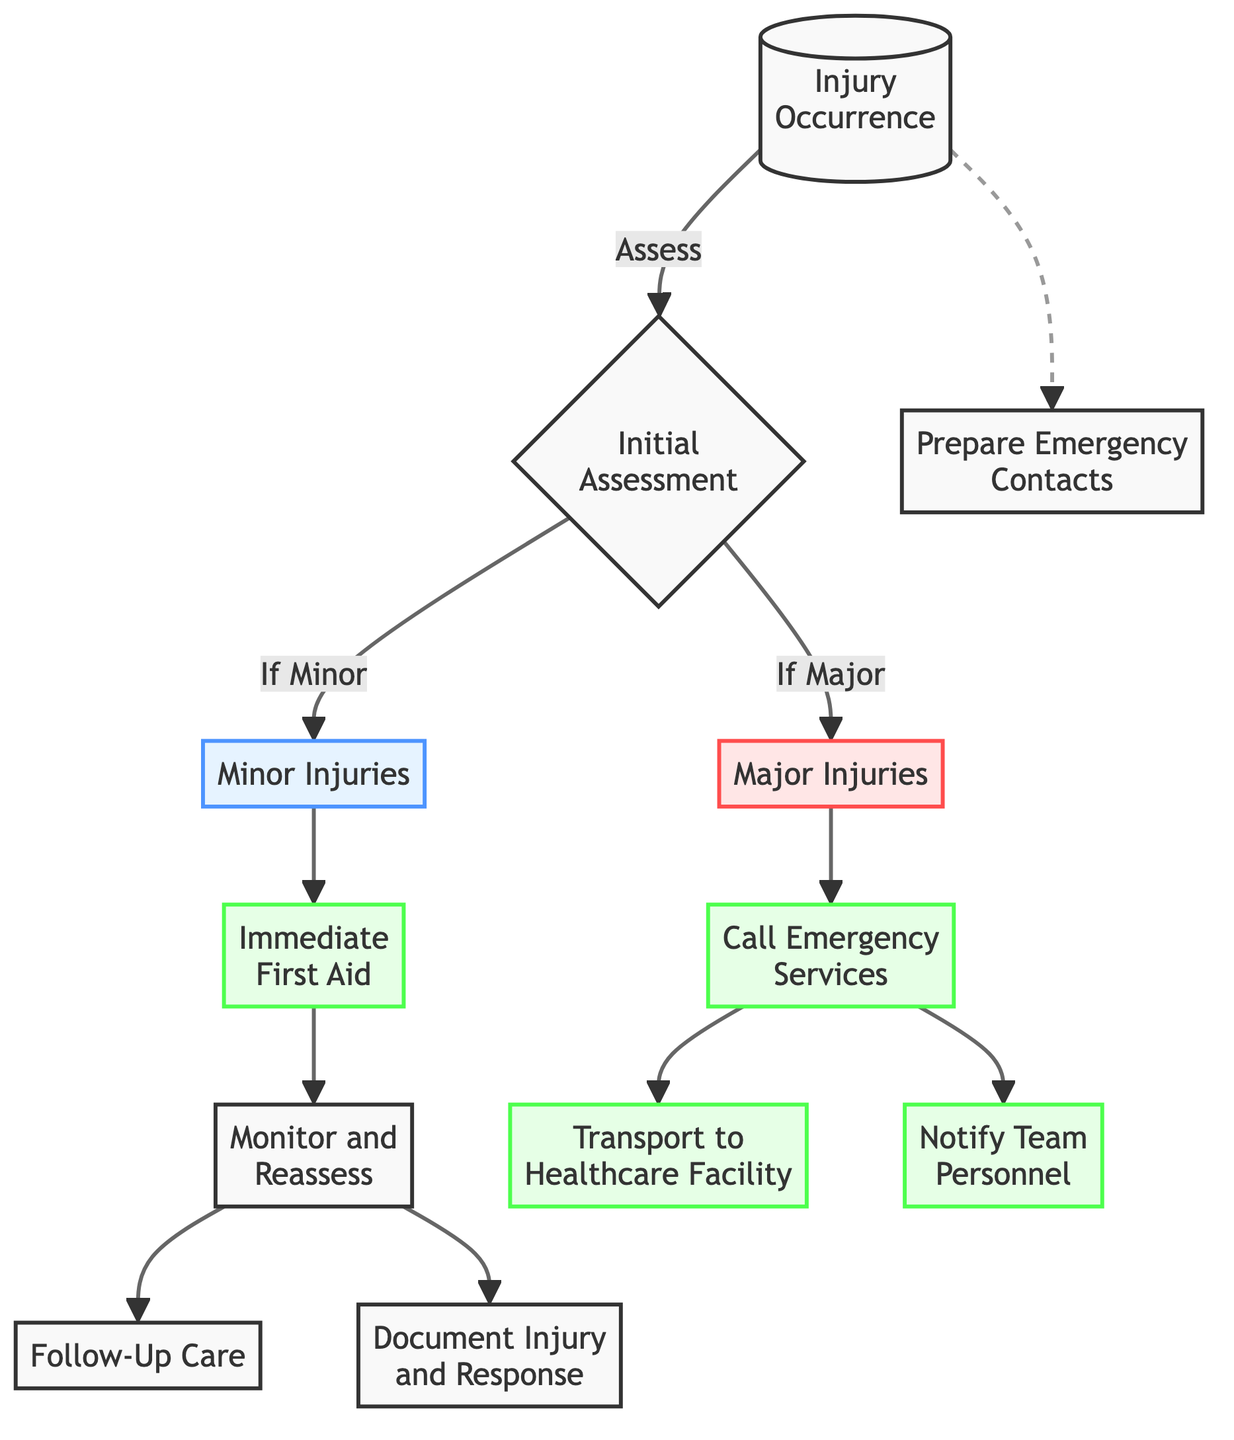What is the first step after an injury occurs? The first step after an injury occurs is to perform an "Initial Assessment," which is represented directly by the node following "Injury Occurrence."
Answer: Initial Assessment How many types of injuries are identified in the diagram? The diagram identifies two types of injuries: "Minor Injuries" and "Major Injuries." These are represented as two separate nodes stemming from the "Initial Assessment" node.
Answer: Two What action should be taken for a minor injury? For a minor injury, the action that should be taken is "Immediate First Aid," as indicated directly following the "Minor Injuries" node.
Answer: Immediate First Aid What happens after notifying team personnel? After notifying team personnel, the next action is "Transport to Healthcare Facility" when dealing with major injuries, as indicated in the diagram flow.
Answer: Transport to Healthcare Facility If an assessment indicates a major injury, what is the first action? If an assessment indicates a major injury, the first action is to "Call Emergency Services," directly following the "Major Injuries" node in the flow.
Answer: Call Emergency Services How many follow-up actions are prompted after monitoring and reassessing? After monitoring and reassessing the situation, there are two follow-up actions prompted: "Document Injury and Response" and "Follow-Up Care." Therefore, the answer is two actions.
Answer: Two actions Which type of injury is associated with the color code "majorStyle"? The "Major Injuries" node is associated with the color code "majorStyle," which is represented in the diagram as a red style.
Answer: Major Injuries What is the relationship between "Initial Assessment" and "Monitor and Reassess"? The relationship is sequential; after the "Initial Assessment" is completed, the flow leads to monitoring and reassessing the injury condition, indicating a stepwise approach to handling injuries.
Answer: Sequential What node does "Prepare Emergency Contacts" connect to, and what type of relationship is depicted? The "Prepare Emergency Contacts" node has a dashed line connecting to the "Injury Occurrence," indicating a non-sequential, preparatory action that is needed whenever an injury occurs, but is not directly dependent on the subsequent steps.
Answer: Non-sequential connection 